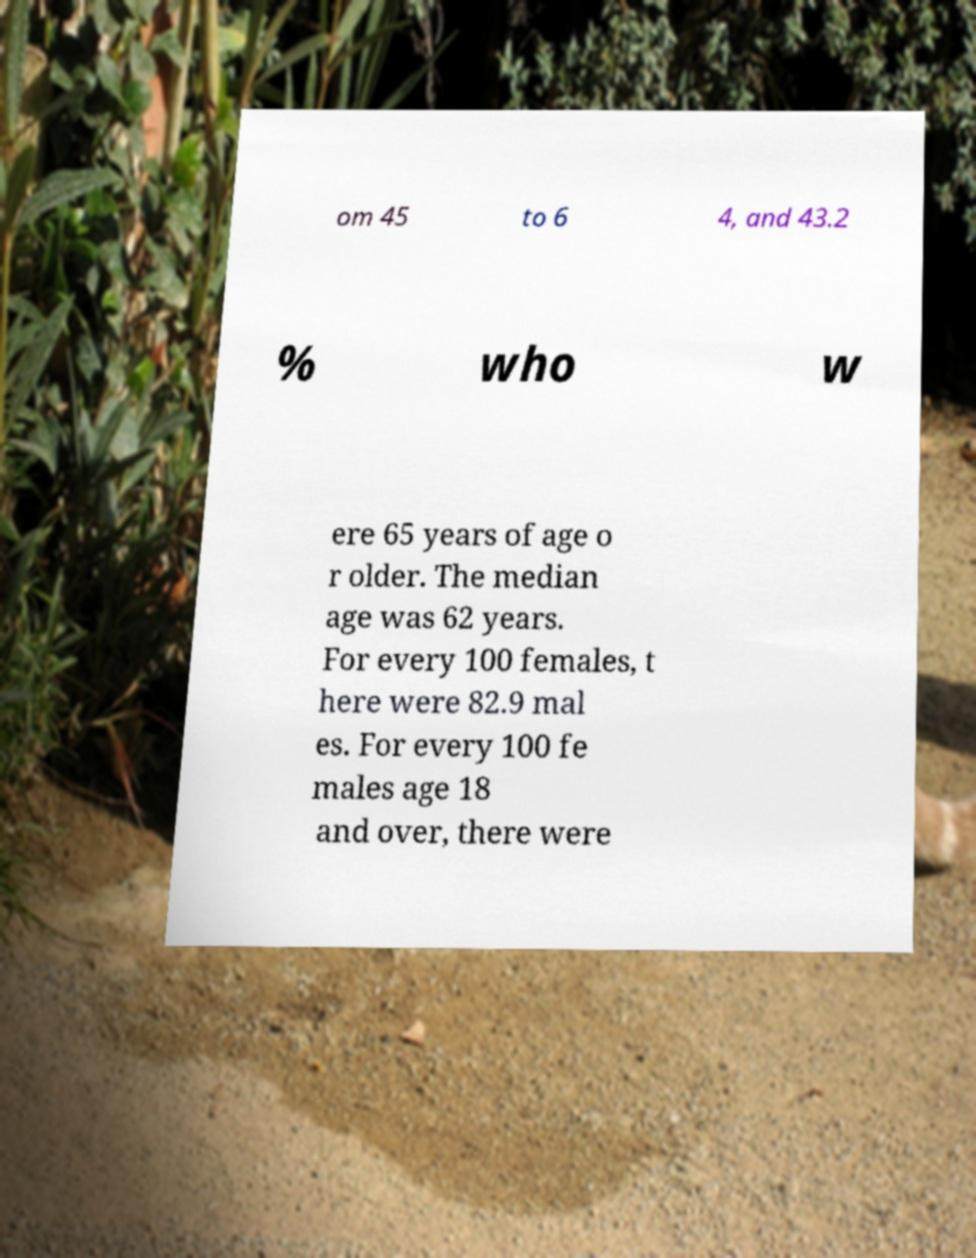Please read and relay the text visible in this image. What does it say? om 45 to 6 4, and 43.2 % who w ere 65 years of age o r older. The median age was 62 years. For every 100 females, t here were 82.9 mal es. For every 100 fe males age 18 and over, there were 